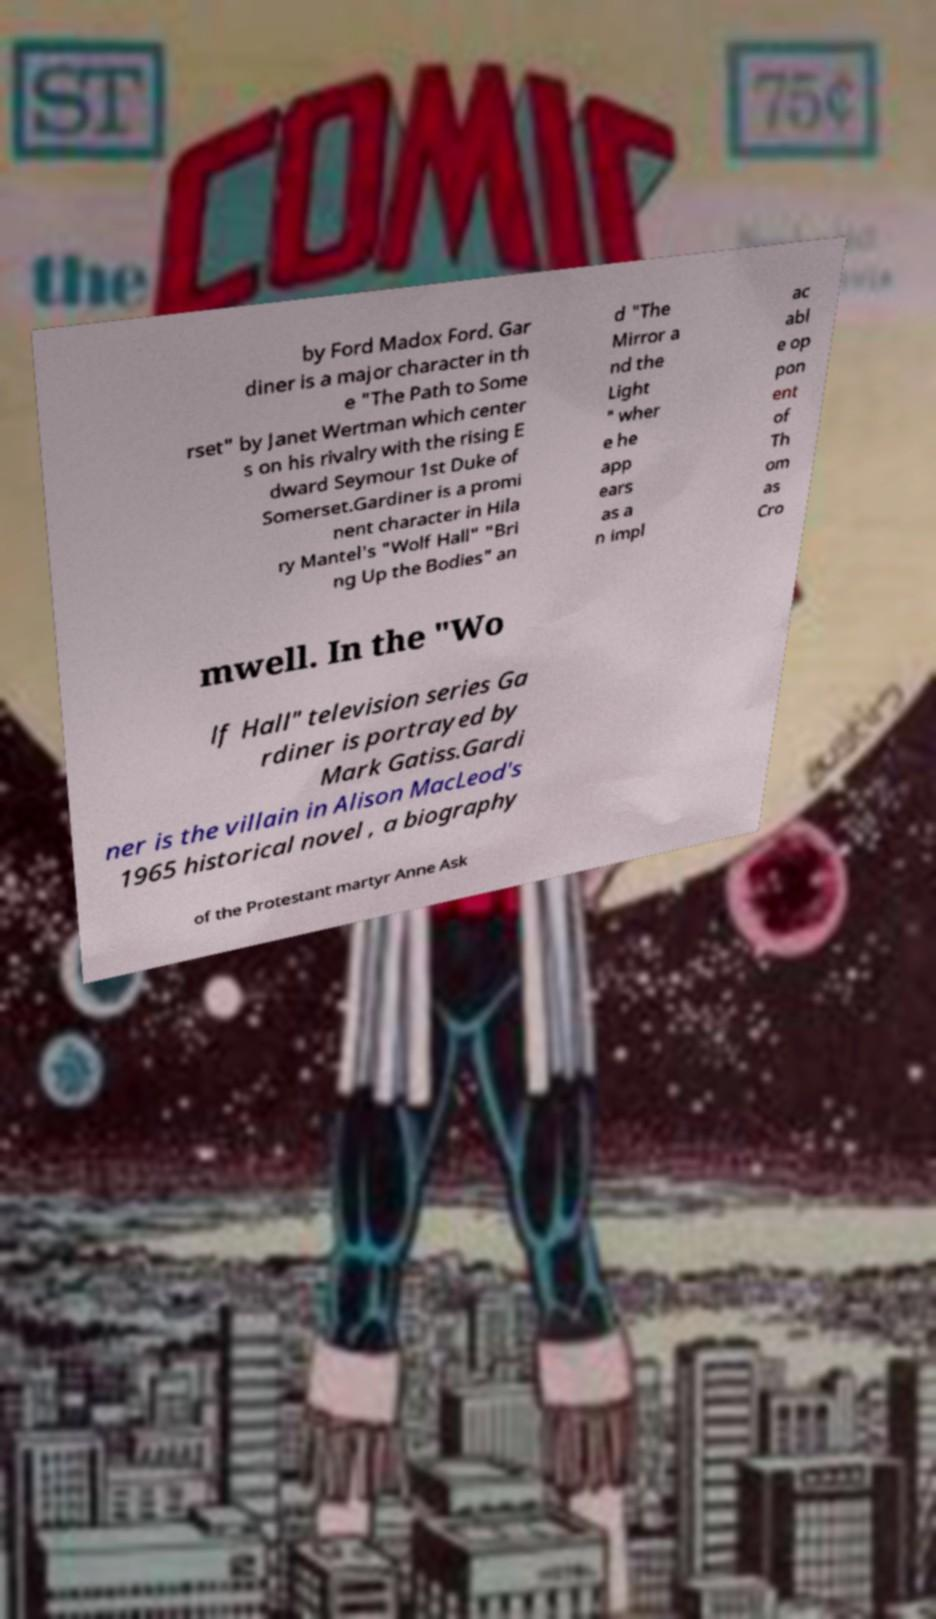Can you read and provide the text displayed in the image?This photo seems to have some interesting text. Can you extract and type it out for me? by Ford Madox Ford. Gar diner is a major character in th e "The Path to Some rset" by Janet Wertman which center s on his rivalry with the rising E dward Seymour 1st Duke of Somerset.Gardiner is a promi nent character in Hila ry Mantel's "Wolf Hall" "Bri ng Up the Bodies" an d "The Mirror a nd the Light " wher e he app ears as a n impl ac abl e op pon ent of Th om as Cro mwell. In the "Wo lf Hall" television series Ga rdiner is portrayed by Mark Gatiss.Gardi ner is the villain in Alison MacLeod's 1965 historical novel , a biography of the Protestant martyr Anne Ask 